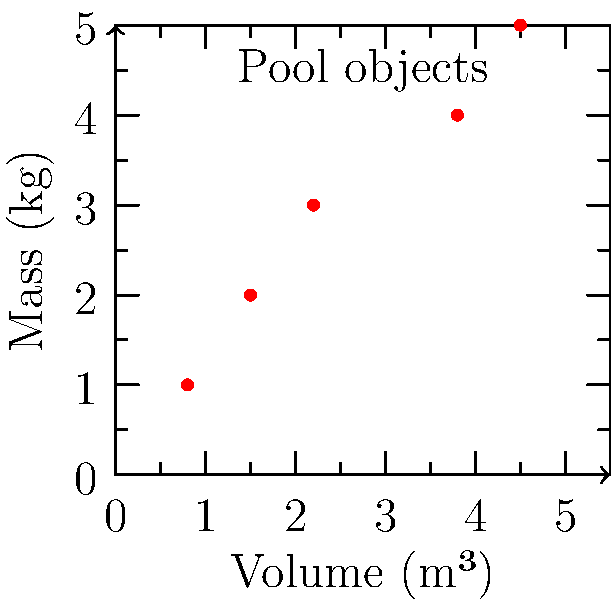You're relaxing by the pool in Seychelles when you notice some objects floating in the water. The graph shows the mass and volume of five different objects. Which object is most likely to sink in the pool water? (Assume the density of pool water is 1000 kg/m³) To determine which object is most likely to sink, we need to compare the density of each object to the density of pool water. The object with the highest density relative to water will be most likely to sink.

1. Recall the formula for density: $\text{Density} = \frac{\text{Mass}}{\text{Volume}}$

2. Calculate the density of each object:
   Object 1: $\frac{1 \text{ kg}}{0.8 \text{ m}^3} = 1250 \text{ kg/m}^3$
   Object 2: $\frac{2 \text{ kg}}{1.5 \text{ m}^3} \approx 1333 \text{ kg/m}^3$
   Object 3: $\frac{3 \text{ kg}}{2.2 \text{ m}^3} \approx 1364 \text{ kg/m}^3$
   Object 4: $\frac{4 \text{ kg}}{3.8 \text{ m}^3} \approx 1053 \text{ kg/m}^3$
   Object 5: $\frac{5 \text{ kg}}{4.5 \text{ m}^3} \approx 1111 \text{ kg/m}^3$

3. Compare each object's density to water (1000 kg/m³):
   All objects have a density greater than water, so they would all sink.

4. The object with the highest density will sink fastest and is "most likely to sink":
   Object 3 has the highest density at approximately 1364 kg/m³.

Therefore, Object 3 is most likely to sink in the pool water.
Answer: Object 3 